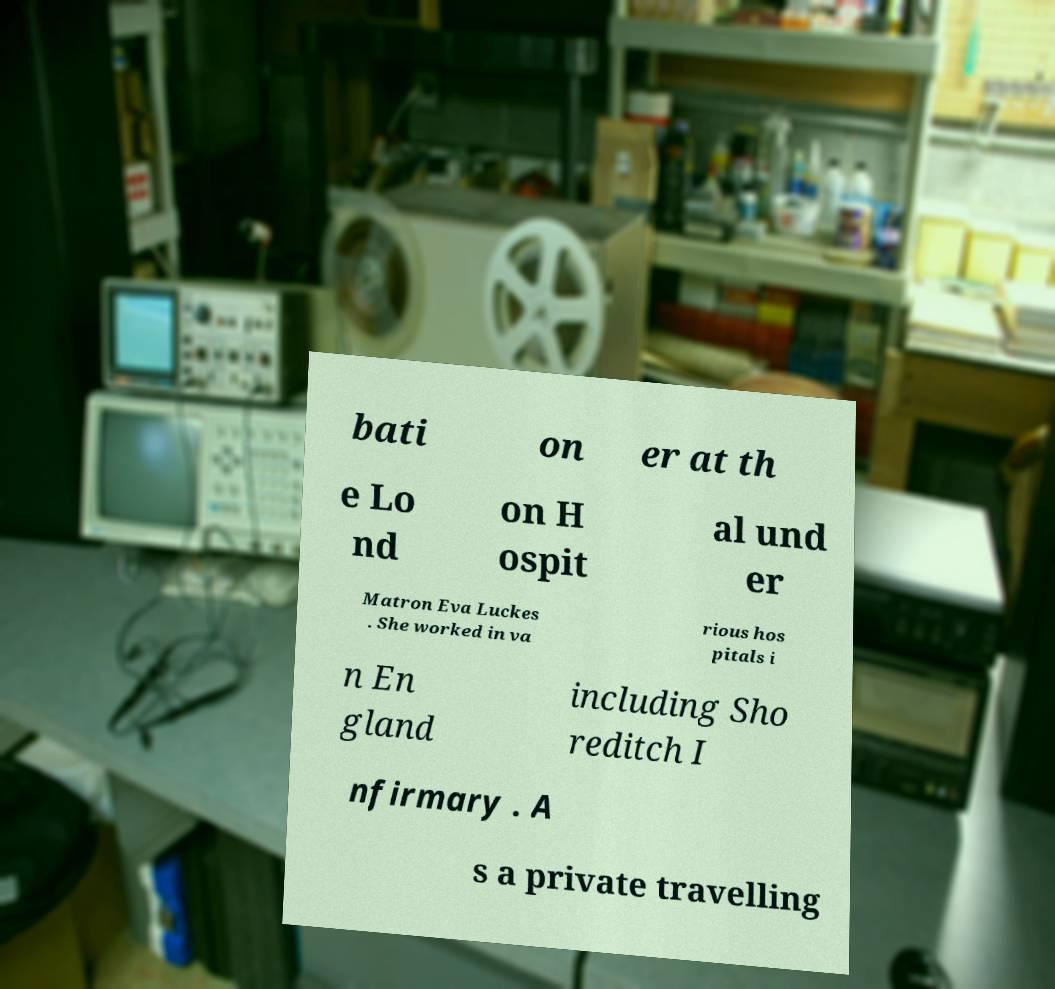Please read and relay the text visible in this image. What does it say? bati on er at th e Lo nd on H ospit al und er Matron Eva Luckes . She worked in va rious hos pitals i n En gland including Sho reditch I nfirmary . A s a private travelling 